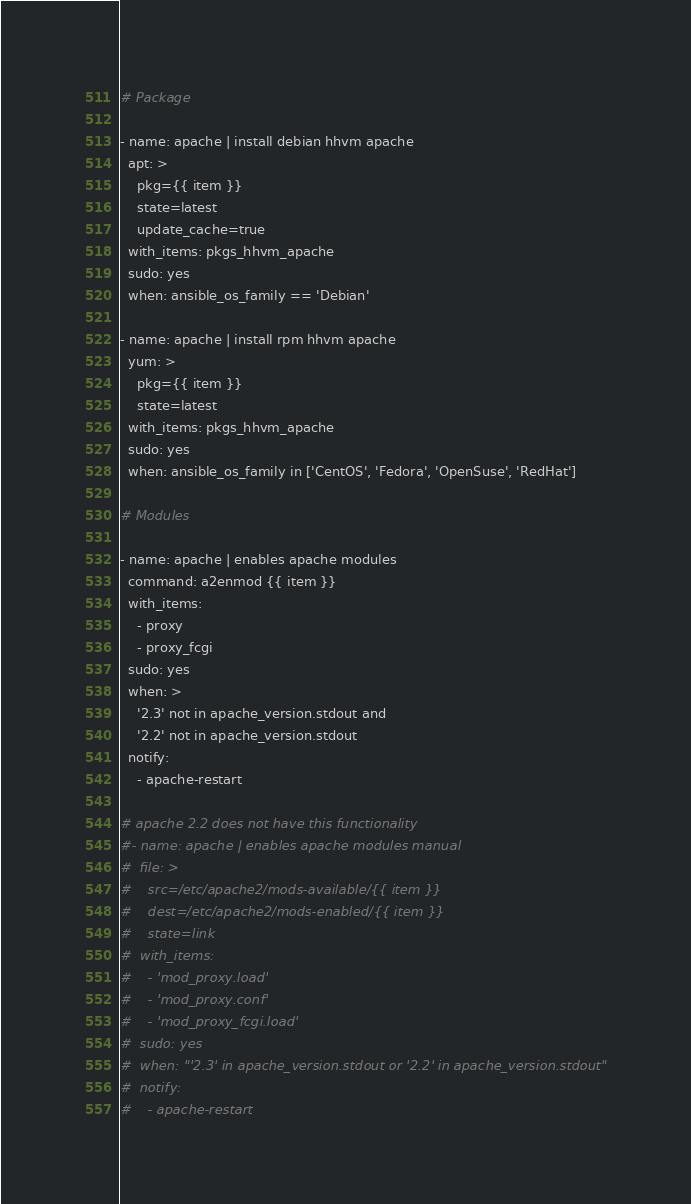<code> <loc_0><loc_0><loc_500><loc_500><_YAML_># Package

- name: apache | install debian hhvm apache
  apt: >
    pkg={{ item }} 
    state=latest
    update_cache=true
  with_items: pkgs_hhvm_apache
  sudo: yes
  when: ansible_os_family == 'Debian'

- name: apache | install rpm hhvm apache
  yum: >
    pkg={{ item }} 
    state=latest
  with_items: pkgs_hhvm_apache
  sudo: yes
  when: ansible_os_family in ['CentOS', 'Fedora', 'OpenSuse', 'RedHat']

# Modules

- name: apache | enables apache modules
  command: a2enmod {{ item }}
  with_items: 
    - proxy
    - proxy_fcgi
  sudo: yes
  when: >
    '2.3' not in apache_version.stdout and 
    '2.2' not in apache_version.stdout
  notify:
    - apache-restart

# apache 2.2 does not have this functionality
#- name: apache | enables apache modules manual
#  file: >
#    src=/etc/apache2/mods-available/{{ item }}
#    dest=/etc/apache2/mods-enabled/{{ item }}
#    state=link
#  with_items: 
#    - 'mod_proxy.load'
#    - 'mod_proxy.conf'
#    - 'mod_proxy_fcgi.load'
#  sudo: yes
#  when: "'2.3' in apache_version.stdout or '2.2' in apache_version.stdout"
#  notify:
#    - apache-restart</code> 